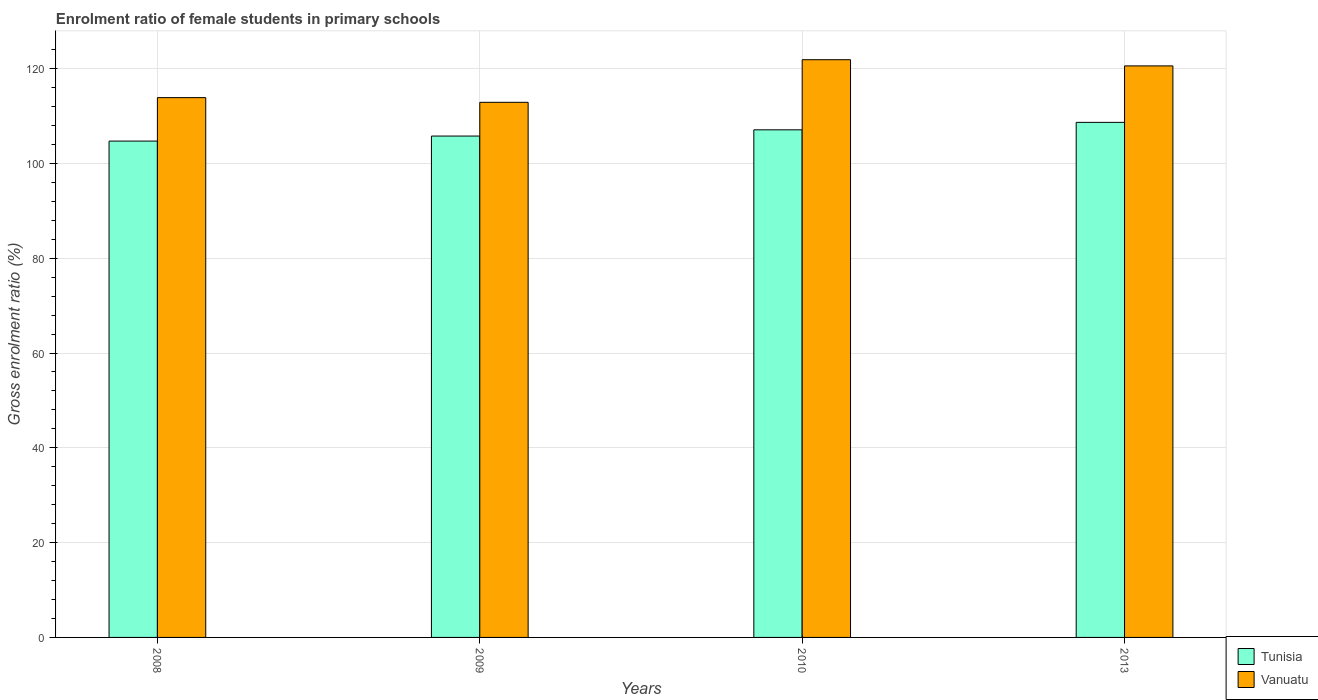How many different coloured bars are there?
Provide a short and direct response. 2. Are the number of bars per tick equal to the number of legend labels?
Provide a succinct answer. Yes. Are the number of bars on each tick of the X-axis equal?
Keep it short and to the point. Yes. How many bars are there on the 4th tick from the right?
Your response must be concise. 2. What is the label of the 1st group of bars from the left?
Your answer should be compact. 2008. In how many cases, is the number of bars for a given year not equal to the number of legend labels?
Provide a short and direct response. 0. What is the enrolment ratio of female students in primary schools in Tunisia in 2009?
Ensure brevity in your answer.  105.78. Across all years, what is the maximum enrolment ratio of female students in primary schools in Tunisia?
Keep it short and to the point. 108.66. Across all years, what is the minimum enrolment ratio of female students in primary schools in Tunisia?
Offer a very short reply. 104.72. In which year was the enrolment ratio of female students in primary schools in Vanuatu minimum?
Keep it short and to the point. 2009. What is the total enrolment ratio of female students in primary schools in Tunisia in the graph?
Give a very brief answer. 426.25. What is the difference between the enrolment ratio of female students in primary schools in Tunisia in 2008 and that in 2013?
Ensure brevity in your answer.  -3.95. What is the difference between the enrolment ratio of female students in primary schools in Vanuatu in 2010 and the enrolment ratio of female students in primary schools in Tunisia in 2009?
Keep it short and to the point. 16.11. What is the average enrolment ratio of female students in primary schools in Tunisia per year?
Provide a succinct answer. 106.56. In the year 2013, what is the difference between the enrolment ratio of female students in primary schools in Vanuatu and enrolment ratio of female students in primary schools in Tunisia?
Make the answer very short. 11.91. What is the ratio of the enrolment ratio of female students in primary schools in Vanuatu in 2008 to that in 2010?
Provide a short and direct response. 0.93. Is the difference between the enrolment ratio of female students in primary schools in Vanuatu in 2009 and 2010 greater than the difference between the enrolment ratio of female students in primary schools in Tunisia in 2009 and 2010?
Offer a very short reply. No. What is the difference between the highest and the second highest enrolment ratio of female students in primary schools in Tunisia?
Offer a very short reply. 1.57. What is the difference between the highest and the lowest enrolment ratio of female students in primary schools in Tunisia?
Give a very brief answer. 3.95. In how many years, is the enrolment ratio of female students in primary schools in Tunisia greater than the average enrolment ratio of female students in primary schools in Tunisia taken over all years?
Offer a terse response. 2. What does the 1st bar from the left in 2008 represents?
Keep it short and to the point. Tunisia. What does the 1st bar from the right in 2013 represents?
Your response must be concise. Vanuatu. How many bars are there?
Your answer should be compact. 8. Are all the bars in the graph horizontal?
Provide a succinct answer. No. How many years are there in the graph?
Provide a succinct answer. 4. Are the values on the major ticks of Y-axis written in scientific E-notation?
Ensure brevity in your answer.  No. Does the graph contain any zero values?
Offer a terse response. No. Where does the legend appear in the graph?
Your response must be concise. Bottom right. How many legend labels are there?
Give a very brief answer. 2. What is the title of the graph?
Provide a short and direct response. Enrolment ratio of female students in primary schools. What is the label or title of the Y-axis?
Keep it short and to the point. Gross enrolment ratio (%). What is the Gross enrolment ratio (%) of Tunisia in 2008?
Give a very brief answer. 104.72. What is the Gross enrolment ratio (%) of Vanuatu in 2008?
Offer a terse response. 113.88. What is the Gross enrolment ratio (%) of Tunisia in 2009?
Provide a succinct answer. 105.78. What is the Gross enrolment ratio (%) of Vanuatu in 2009?
Your answer should be compact. 112.89. What is the Gross enrolment ratio (%) of Tunisia in 2010?
Provide a short and direct response. 107.09. What is the Gross enrolment ratio (%) of Vanuatu in 2010?
Your answer should be very brief. 121.88. What is the Gross enrolment ratio (%) in Tunisia in 2013?
Your answer should be compact. 108.66. What is the Gross enrolment ratio (%) in Vanuatu in 2013?
Keep it short and to the point. 120.58. Across all years, what is the maximum Gross enrolment ratio (%) in Tunisia?
Your answer should be compact. 108.66. Across all years, what is the maximum Gross enrolment ratio (%) of Vanuatu?
Provide a short and direct response. 121.88. Across all years, what is the minimum Gross enrolment ratio (%) in Tunisia?
Ensure brevity in your answer.  104.72. Across all years, what is the minimum Gross enrolment ratio (%) in Vanuatu?
Ensure brevity in your answer.  112.89. What is the total Gross enrolment ratio (%) of Tunisia in the graph?
Keep it short and to the point. 426.25. What is the total Gross enrolment ratio (%) of Vanuatu in the graph?
Your answer should be compact. 469.23. What is the difference between the Gross enrolment ratio (%) in Tunisia in 2008 and that in 2009?
Provide a succinct answer. -1.06. What is the difference between the Gross enrolment ratio (%) of Tunisia in 2008 and that in 2010?
Ensure brevity in your answer.  -2.38. What is the difference between the Gross enrolment ratio (%) in Vanuatu in 2008 and that in 2010?
Your response must be concise. -8. What is the difference between the Gross enrolment ratio (%) of Tunisia in 2008 and that in 2013?
Ensure brevity in your answer.  -3.95. What is the difference between the Gross enrolment ratio (%) of Vanuatu in 2008 and that in 2013?
Provide a short and direct response. -6.7. What is the difference between the Gross enrolment ratio (%) of Tunisia in 2009 and that in 2010?
Offer a very short reply. -1.32. What is the difference between the Gross enrolment ratio (%) in Vanuatu in 2009 and that in 2010?
Offer a very short reply. -8.99. What is the difference between the Gross enrolment ratio (%) of Tunisia in 2009 and that in 2013?
Keep it short and to the point. -2.89. What is the difference between the Gross enrolment ratio (%) in Vanuatu in 2009 and that in 2013?
Ensure brevity in your answer.  -7.69. What is the difference between the Gross enrolment ratio (%) of Tunisia in 2010 and that in 2013?
Provide a succinct answer. -1.57. What is the difference between the Gross enrolment ratio (%) in Vanuatu in 2010 and that in 2013?
Offer a very short reply. 1.31. What is the difference between the Gross enrolment ratio (%) of Tunisia in 2008 and the Gross enrolment ratio (%) of Vanuatu in 2009?
Offer a terse response. -8.18. What is the difference between the Gross enrolment ratio (%) in Tunisia in 2008 and the Gross enrolment ratio (%) in Vanuatu in 2010?
Provide a short and direct response. -17.17. What is the difference between the Gross enrolment ratio (%) of Tunisia in 2008 and the Gross enrolment ratio (%) of Vanuatu in 2013?
Keep it short and to the point. -15.86. What is the difference between the Gross enrolment ratio (%) of Tunisia in 2009 and the Gross enrolment ratio (%) of Vanuatu in 2010?
Keep it short and to the point. -16.11. What is the difference between the Gross enrolment ratio (%) in Tunisia in 2009 and the Gross enrolment ratio (%) in Vanuatu in 2013?
Keep it short and to the point. -14.8. What is the difference between the Gross enrolment ratio (%) in Tunisia in 2010 and the Gross enrolment ratio (%) in Vanuatu in 2013?
Your answer should be very brief. -13.49. What is the average Gross enrolment ratio (%) in Tunisia per year?
Your answer should be very brief. 106.56. What is the average Gross enrolment ratio (%) in Vanuatu per year?
Keep it short and to the point. 117.31. In the year 2008, what is the difference between the Gross enrolment ratio (%) of Tunisia and Gross enrolment ratio (%) of Vanuatu?
Make the answer very short. -9.17. In the year 2009, what is the difference between the Gross enrolment ratio (%) of Tunisia and Gross enrolment ratio (%) of Vanuatu?
Your answer should be compact. -7.12. In the year 2010, what is the difference between the Gross enrolment ratio (%) of Tunisia and Gross enrolment ratio (%) of Vanuatu?
Offer a very short reply. -14.79. In the year 2013, what is the difference between the Gross enrolment ratio (%) in Tunisia and Gross enrolment ratio (%) in Vanuatu?
Provide a short and direct response. -11.91. What is the ratio of the Gross enrolment ratio (%) of Vanuatu in 2008 to that in 2009?
Provide a short and direct response. 1.01. What is the ratio of the Gross enrolment ratio (%) of Tunisia in 2008 to that in 2010?
Your answer should be compact. 0.98. What is the ratio of the Gross enrolment ratio (%) in Vanuatu in 2008 to that in 2010?
Offer a very short reply. 0.93. What is the ratio of the Gross enrolment ratio (%) of Tunisia in 2008 to that in 2013?
Make the answer very short. 0.96. What is the ratio of the Gross enrolment ratio (%) of Vanuatu in 2008 to that in 2013?
Provide a short and direct response. 0.94. What is the ratio of the Gross enrolment ratio (%) of Vanuatu in 2009 to that in 2010?
Your response must be concise. 0.93. What is the ratio of the Gross enrolment ratio (%) in Tunisia in 2009 to that in 2013?
Offer a very short reply. 0.97. What is the ratio of the Gross enrolment ratio (%) in Vanuatu in 2009 to that in 2013?
Your response must be concise. 0.94. What is the ratio of the Gross enrolment ratio (%) in Tunisia in 2010 to that in 2013?
Ensure brevity in your answer.  0.99. What is the ratio of the Gross enrolment ratio (%) of Vanuatu in 2010 to that in 2013?
Ensure brevity in your answer.  1.01. What is the difference between the highest and the second highest Gross enrolment ratio (%) of Tunisia?
Provide a succinct answer. 1.57. What is the difference between the highest and the second highest Gross enrolment ratio (%) of Vanuatu?
Give a very brief answer. 1.31. What is the difference between the highest and the lowest Gross enrolment ratio (%) of Tunisia?
Give a very brief answer. 3.95. What is the difference between the highest and the lowest Gross enrolment ratio (%) in Vanuatu?
Make the answer very short. 8.99. 